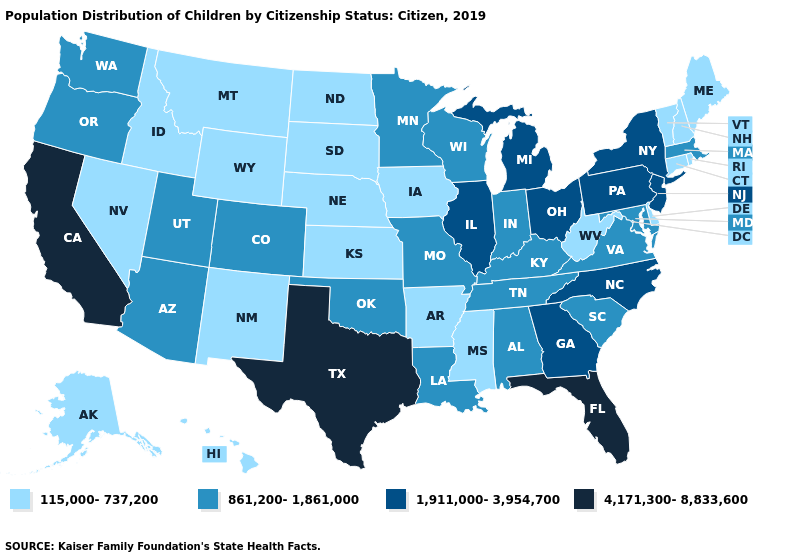Name the states that have a value in the range 1,911,000-3,954,700?
Quick response, please. Georgia, Illinois, Michigan, New Jersey, New York, North Carolina, Ohio, Pennsylvania. What is the highest value in the South ?
Give a very brief answer. 4,171,300-8,833,600. Is the legend a continuous bar?
Answer briefly. No. What is the lowest value in states that border Kentucky?
Short answer required. 115,000-737,200. Does Michigan have the highest value in the MidWest?
Keep it brief. Yes. What is the highest value in the West ?
Short answer required. 4,171,300-8,833,600. Which states have the highest value in the USA?
Keep it brief. California, Florida, Texas. Name the states that have a value in the range 4,171,300-8,833,600?
Give a very brief answer. California, Florida, Texas. Among the states that border Texas , does Arkansas have the highest value?
Be succinct. No. Does Maryland have the lowest value in the USA?
Short answer required. No. Does the first symbol in the legend represent the smallest category?
Short answer required. Yes. Among the states that border New Hampshire , does Vermont have the highest value?
Concise answer only. No. What is the value of Nevada?
Keep it brief. 115,000-737,200. Name the states that have a value in the range 115,000-737,200?
Quick response, please. Alaska, Arkansas, Connecticut, Delaware, Hawaii, Idaho, Iowa, Kansas, Maine, Mississippi, Montana, Nebraska, Nevada, New Hampshire, New Mexico, North Dakota, Rhode Island, South Dakota, Vermont, West Virginia, Wyoming. Does Iowa have the same value as Kansas?
Keep it brief. Yes. 